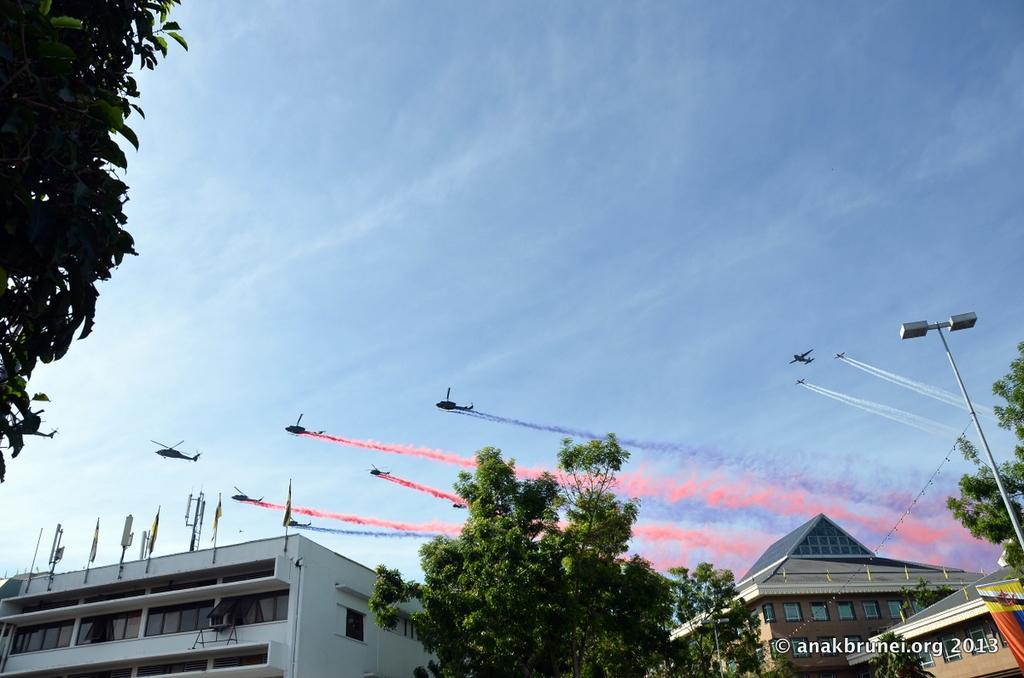In one or two sentences, can you explain what this image depicts? At the bottom there are buildings,poles,trees,windows,banner on the right side,poles and flags on the building on the left side. In the background there are helicopters and aeroplanes flying in the sky. On the left there is a tree and we can see smoke in different colors in the sky and there are clouds in the sky. 